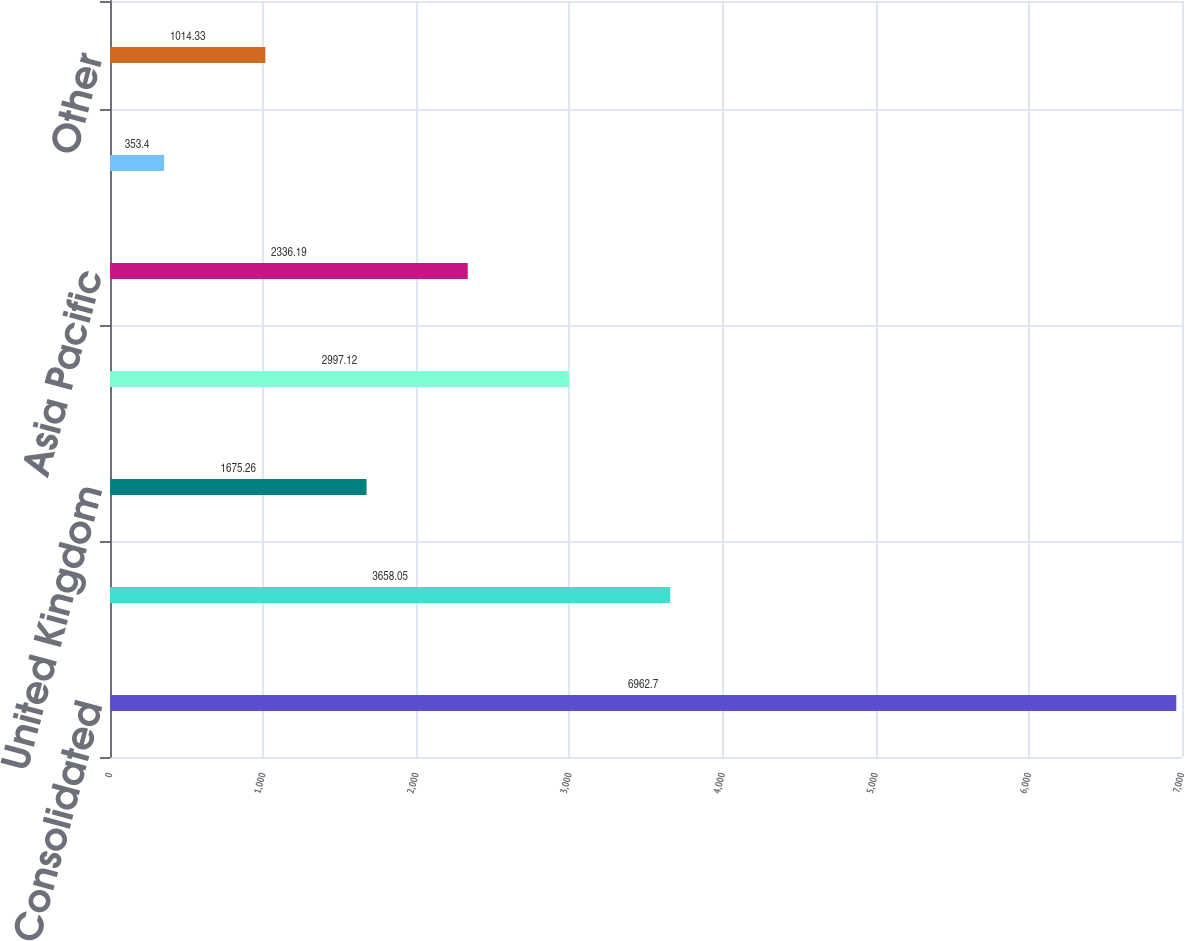<chart> <loc_0><loc_0><loc_500><loc_500><bar_chart><fcel>Consolidated<fcel>International<fcel>United Kingdom<fcel>Continental Europe<fcel>Asia Pacific<fcel>Latin America<fcel>Other<nl><fcel>6962.7<fcel>3658.05<fcel>1675.26<fcel>2997.12<fcel>2336.19<fcel>353.4<fcel>1014.33<nl></chart> 